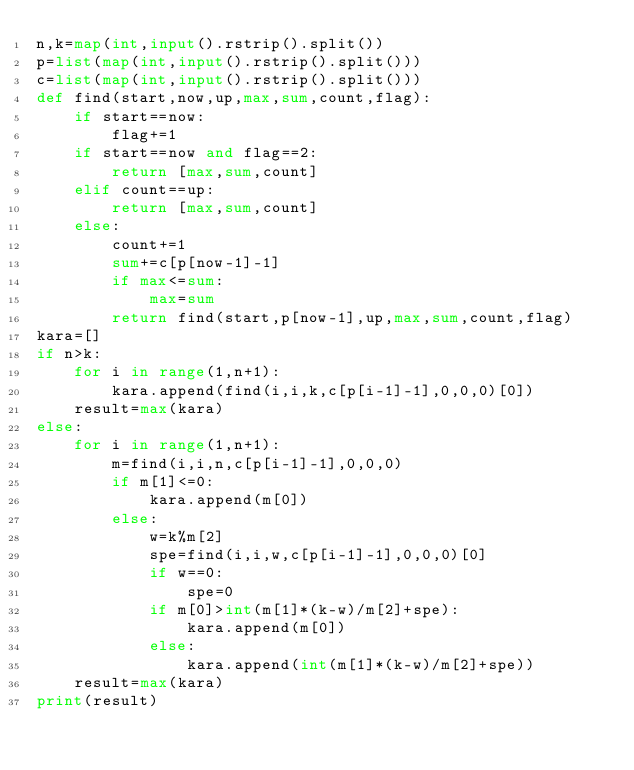<code> <loc_0><loc_0><loc_500><loc_500><_Python_>n,k=map(int,input().rstrip().split())
p=list(map(int,input().rstrip().split()))
c=list(map(int,input().rstrip().split()))
def find(start,now,up,max,sum,count,flag):
    if start==now:
        flag+=1
    if start==now and flag==2:
        return [max,sum,count]
    elif count==up:
        return [max,sum,count]
    else:
        count+=1
        sum+=c[p[now-1]-1]
        if max<=sum:
            max=sum
        return find(start,p[now-1],up,max,sum,count,flag)
kara=[]
if n>k:
    for i in range(1,n+1):
        kara.append(find(i,i,k,c[p[i-1]-1],0,0,0)[0])
    result=max(kara)
else:
    for i in range(1,n+1):
        m=find(i,i,n,c[p[i-1]-1],0,0,0)
        if m[1]<=0:
            kara.append(m[0])
        else:
            w=k%m[2]
            spe=find(i,i,w,c[p[i-1]-1],0,0,0)[0]
            if w==0:
                spe=0
            if m[0]>int(m[1]*(k-w)/m[2]+spe):
                kara.append(m[0])
            else:
                kara.append(int(m[1]*(k-w)/m[2]+spe))
    result=max(kara)
print(result)
</code> 